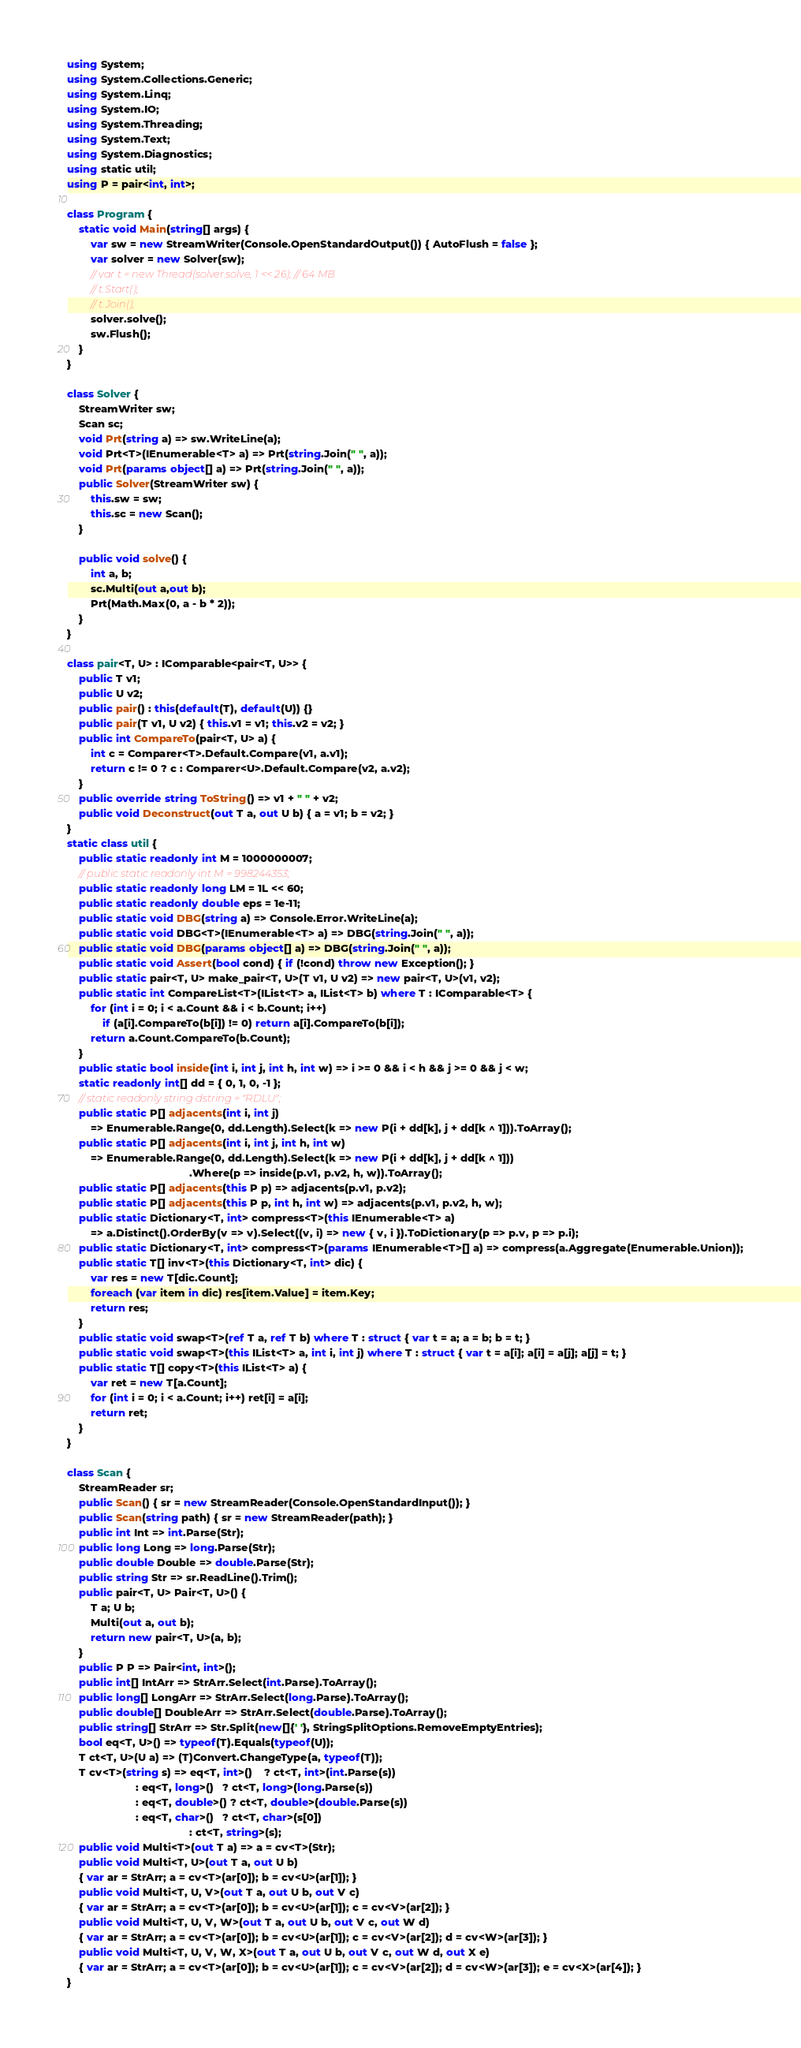<code> <loc_0><loc_0><loc_500><loc_500><_C#_>using System;
using System.Collections.Generic;
using System.Linq;
using System.IO;
using System.Threading;
using System.Text;
using System.Diagnostics;
using static util;
using P = pair<int, int>;

class Program {
    static void Main(string[] args) {
        var sw = new StreamWriter(Console.OpenStandardOutput()) { AutoFlush = false };
        var solver = new Solver(sw);
        // var t = new Thread(solver.solve, 1 << 26); // 64 MB
        // t.Start();
        // t.Join();
        solver.solve();
        sw.Flush();
    }
}

class Solver {
    StreamWriter sw;
    Scan sc;
    void Prt(string a) => sw.WriteLine(a);
    void Prt<T>(IEnumerable<T> a) => Prt(string.Join(" ", a));
    void Prt(params object[] a) => Prt(string.Join(" ", a));
    public Solver(StreamWriter sw) {
        this.sw = sw;
        this.sc = new Scan();
    }

    public void solve() {
        int a, b;
        sc.Multi(out a,out b);
        Prt(Math.Max(0, a - b * 2));
    }
}

class pair<T, U> : IComparable<pair<T, U>> {
    public T v1;
    public U v2;
    public pair() : this(default(T), default(U)) {}
    public pair(T v1, U v2) { this.v1 = v1; this.v2 = v2; }
    public int CompareTo(pair<T, U> a) {
        int c = Comparer<T>.Default.Compare(v1, a.v1);
        return c != 0 ? c : Comparer<U>.Default.Compare(v2, a.v2);
    }
    public override string ToString() => v1 + " " + v2;
    public void Deconstruct(out T a, out U b) { a = v1; b = v2; }
}
static class util {
    public static readonly int M = 1000000007;
    // public static readonly int M = 998244353;
    public static readonly long LM = 1L << 60;
    public static readonly double eps = 1e-11;
    public static void DBG(string a) => Console.Error.WriteLine(a);
    public static void DBG<T>(IEnumerable<T> a) => DBG(string.Join(" ", a));
    public static void DBG(params object[] a) => DBG(string.Join(" ", a));
    public static void Assert(bool cond) { if (!cond) throw new Exception(); }
    public static pair<T, U> make_pair<T, U>(T v1, U v2) => new pair<T, U>(v1, v2);
    public static int CompareList<T>(IList<T> a, IList<T> b) where T : IComparable<T> {
        for (int i = 0; i < a.Count && i < b.Count; i++)
            if (a[i].CompareTo(b[i]) != 0) return a[i].CompareTo(b[i]);
        return a.Count.CompareTo(b.Count);
    }
    public static bool inside(int i, int j, int h, int w) => i >= 0 && i < h && j >= 0 && j < w;
    static readonly int[] dd = { 0, 1, 0, -1 };
    // static readonly string dstring = "RDLU";
    public static P[] adjacents(int i, int j)
        => Enumerable.Range(0, dd.Length).Select(k => new P(i + dd[k], j + dd[k ^ 1])).ToArray();
    public static P[] adjacents(int i, int j, int h, int w)
        => Enumerable.Range(0, dd.Length).Select(k => new P(i + dd[k], j + dd[k ^ 1]))
                                         .Where(p => inside(p.v1, p.v2, h, w)).ToArray();
    public static P[] adjacents(this P p) => adjacents(p.v1, p.v2);
    public static P[] adjacents(this P p, int h, int w) => adjacents(p.v1, p.v2, h, w);
    public static Dictionary<T, int> compress<T>(this IEnumerable<T> a)
        => a.Distinct().OrderBy(v => v).Select((v, i) => new { v, i }).ToDictionary(p => p.v, p => p.i);
    public static Dictionary<T, int> compress<T>(params IEnumerable<T>[] a) => compress(a.Aggregate(Enumerable.Union));
    public static T[] inv<T>(this Dictionary<T, int> dic) {
        var res = new T[dic.Count];
        foreach (var item in dic) res[item.Value] = item.Key;
        return res;
    }
    public static void swap<T>(ref T a, ref T b) where T : struct { var t = a; a = b; b = t; }
    public static void swap<T>(this IList<T> a, int i, int j) where T : struct { var t = a[i]; a[i] = a[j]; a[j] = t; }
    public static T[] copy<T>(this IList<T> a) {
        var ret = new T[a.Count];
        for (int i = 0; i < a.Count; i++) ret[i] = a[i];
        return ret;
    }
}

class Scan {
    StreamReader sr;
    public Scan() { sr = new StreamReader(Console.OpenStandardInput()); }
    public Scan(string path) { sr = new StreamReader(path); }
    public int Int => int.Parse(Str);
    public long Long => long.Parse(Str);
    public double Double => double.Parse(Str);
    public string Str => sr.ReadLine().Trim();
    public pair<T, U> Pair<T, U>() {
        T a; U b;
        Multi(out a, out b);
        return new pair<T, U>(a, b);
    }
    public P P => Pair<int, int>();
    public int[] IntArr => StrArr.Select(int.Parse).ToArray();
    public long[] LongArr => StrArr.Select(long.Parse).ToArray();
    public double[] DoubleArr => StrArr.Select(double.Parse).ToArray();
    public string[] StrArr => Str.Split(new[]{' '}, StringSplitOptions.RemoveEmptyEntries);
    bool eq<T, U>() => typeof(T).Equals(typeof(U));
    T ct<T, U>(U a) => (T)Convert.ChangeType(a, typeof(T));
    T cv<T>(string s) => eq<T, int>()    ? ct<T, int>(int.Parse(s))
                       : eq<T, long>()   ? ct<T, long>(long.Parse(s))
                       : eq<T, double>() ? ct<T, double>(double.Parse(s))
                       : eq<T, char>()   ? ct<T, char>(s[0])
                                         : ct<T, string>(s);
    public void Multi<T>(out T a) => a = cv<T>(Str);
    public void Multi<T, U>(out T a, out U b)
    { var ar = StrArr; a = cv<T>(ar[0]); b = cv<U>(ar[1]); }
    public void Multi<T, U, V>(out T a, out U b, out V c)
    { var ar = StrArr; a = cv<T>(ar[0]); b = cv<U>(ar[1]); c = cv<V>(ar[2]); }
    public void Multi<T, U, V, W>(out T a, out U b, out V c, out W d)
    { var ar = StrArr; a = cv<T>(ar[0]); b = cv<U>(ar[1]); c = cv<V>(ar[2]); d = cv<W>(ar[3]); }
    public void Multi<T, U, V, W, X>(out T a, out U b, out V c, out W d, out X e)
    { var ar = StrArr; a = cv<T>(ar[0]); b = cv<U>(ar[1]); c = cv<V>(ar[2]); d = cv<W>(ar[3]); e = cv<X>(ar[4]); }
}
</code> 